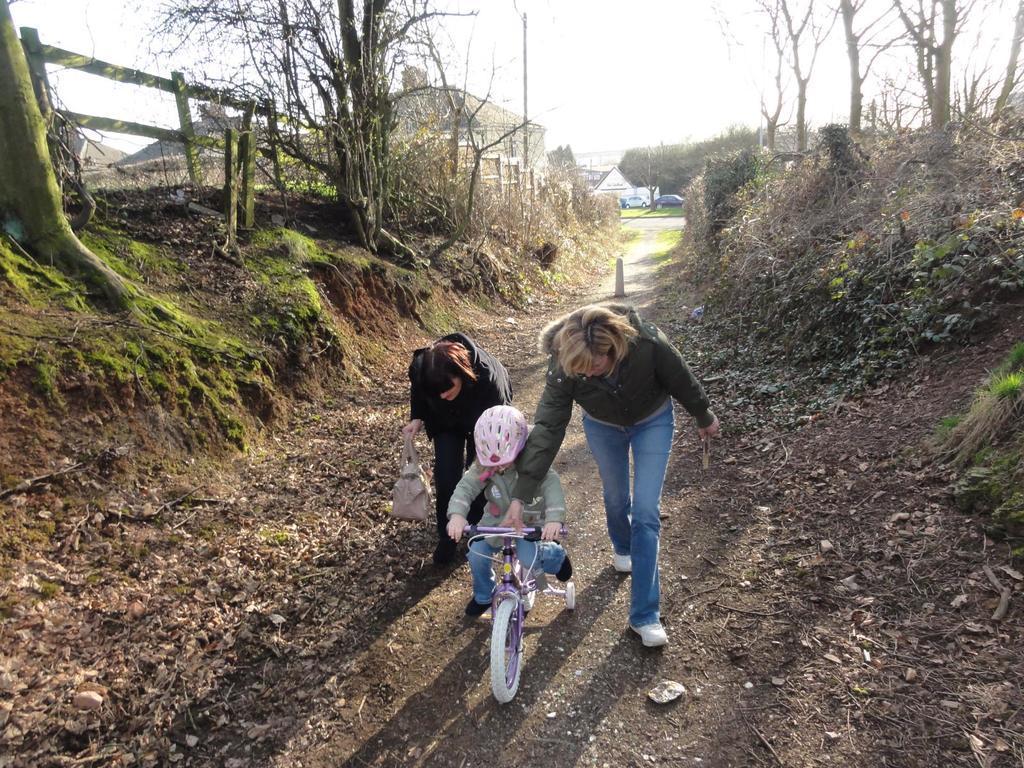Can you describe this image briefly? In this image i can see 2 persons holding a child who is in the bicycle, and in the background i can see buildings, trees, sky and few vehicles. 